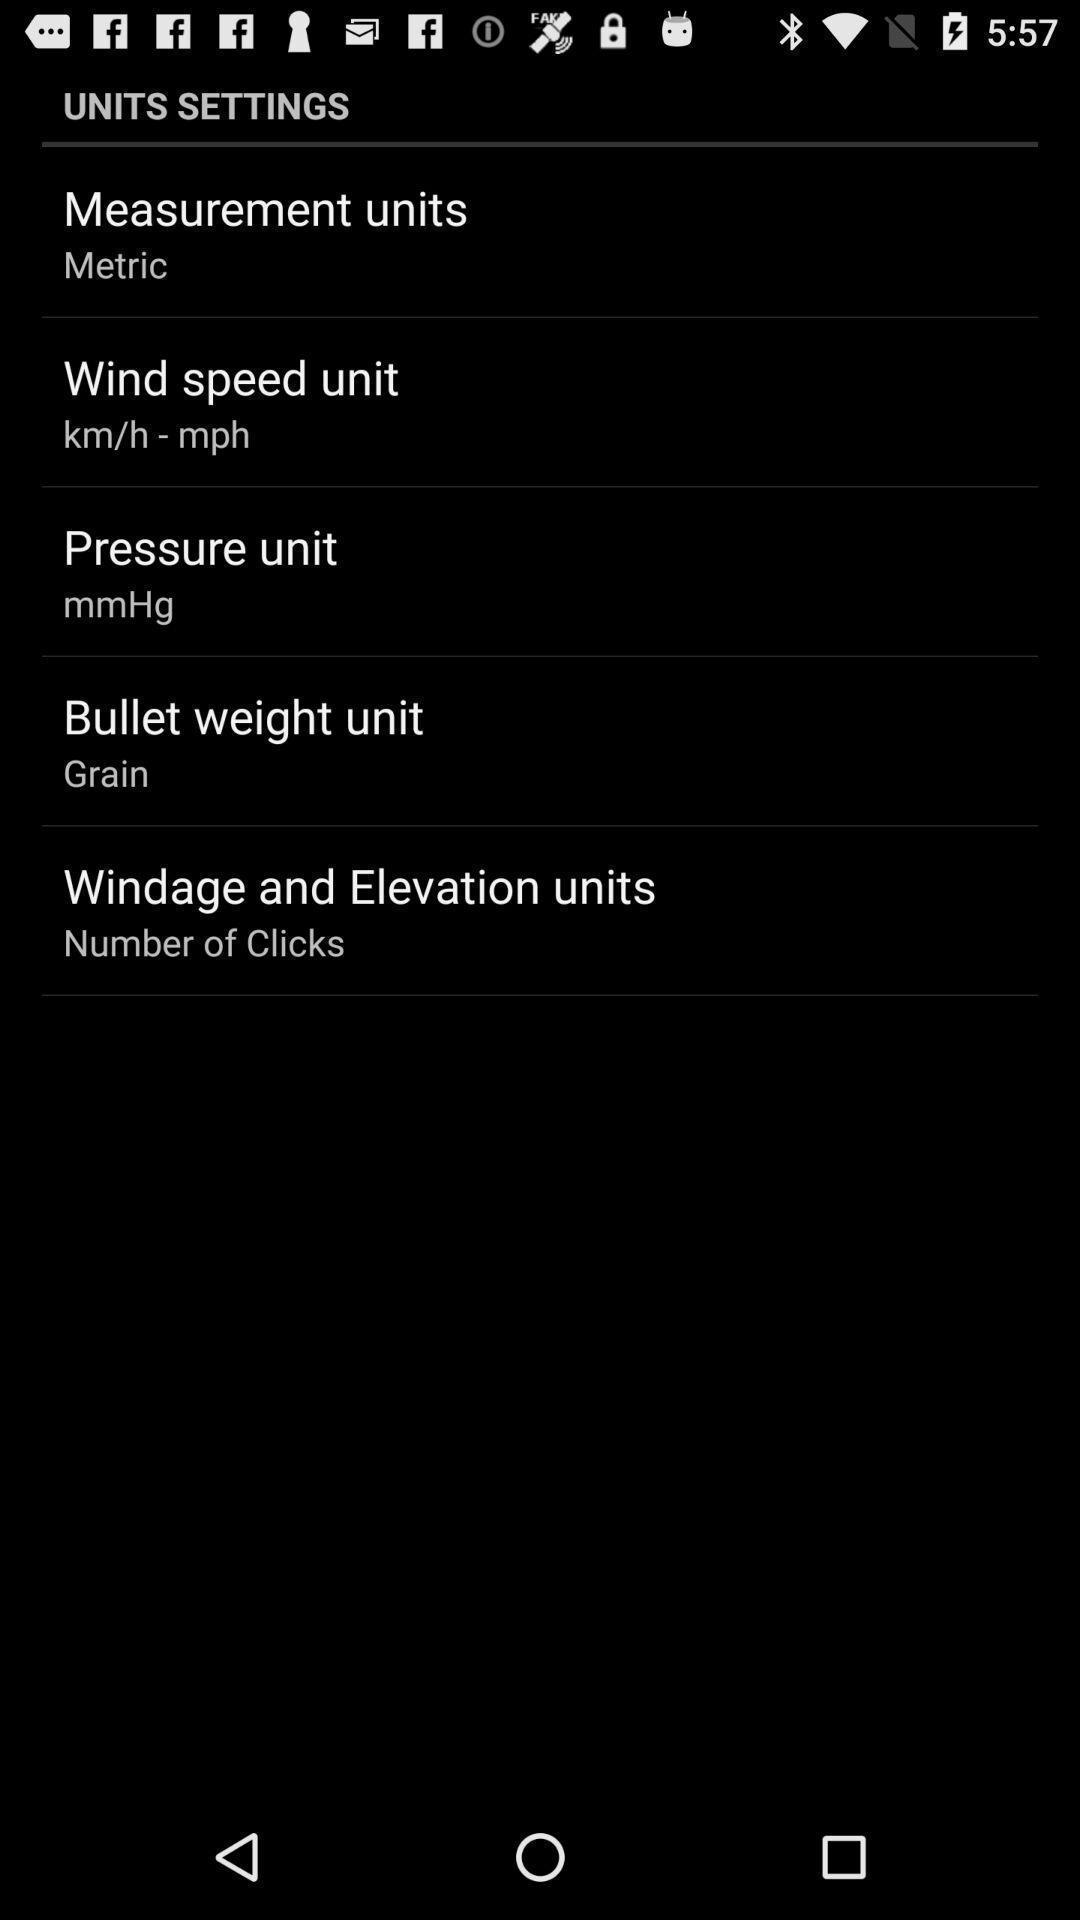Please provide a description for this image. Social app for units settings. 